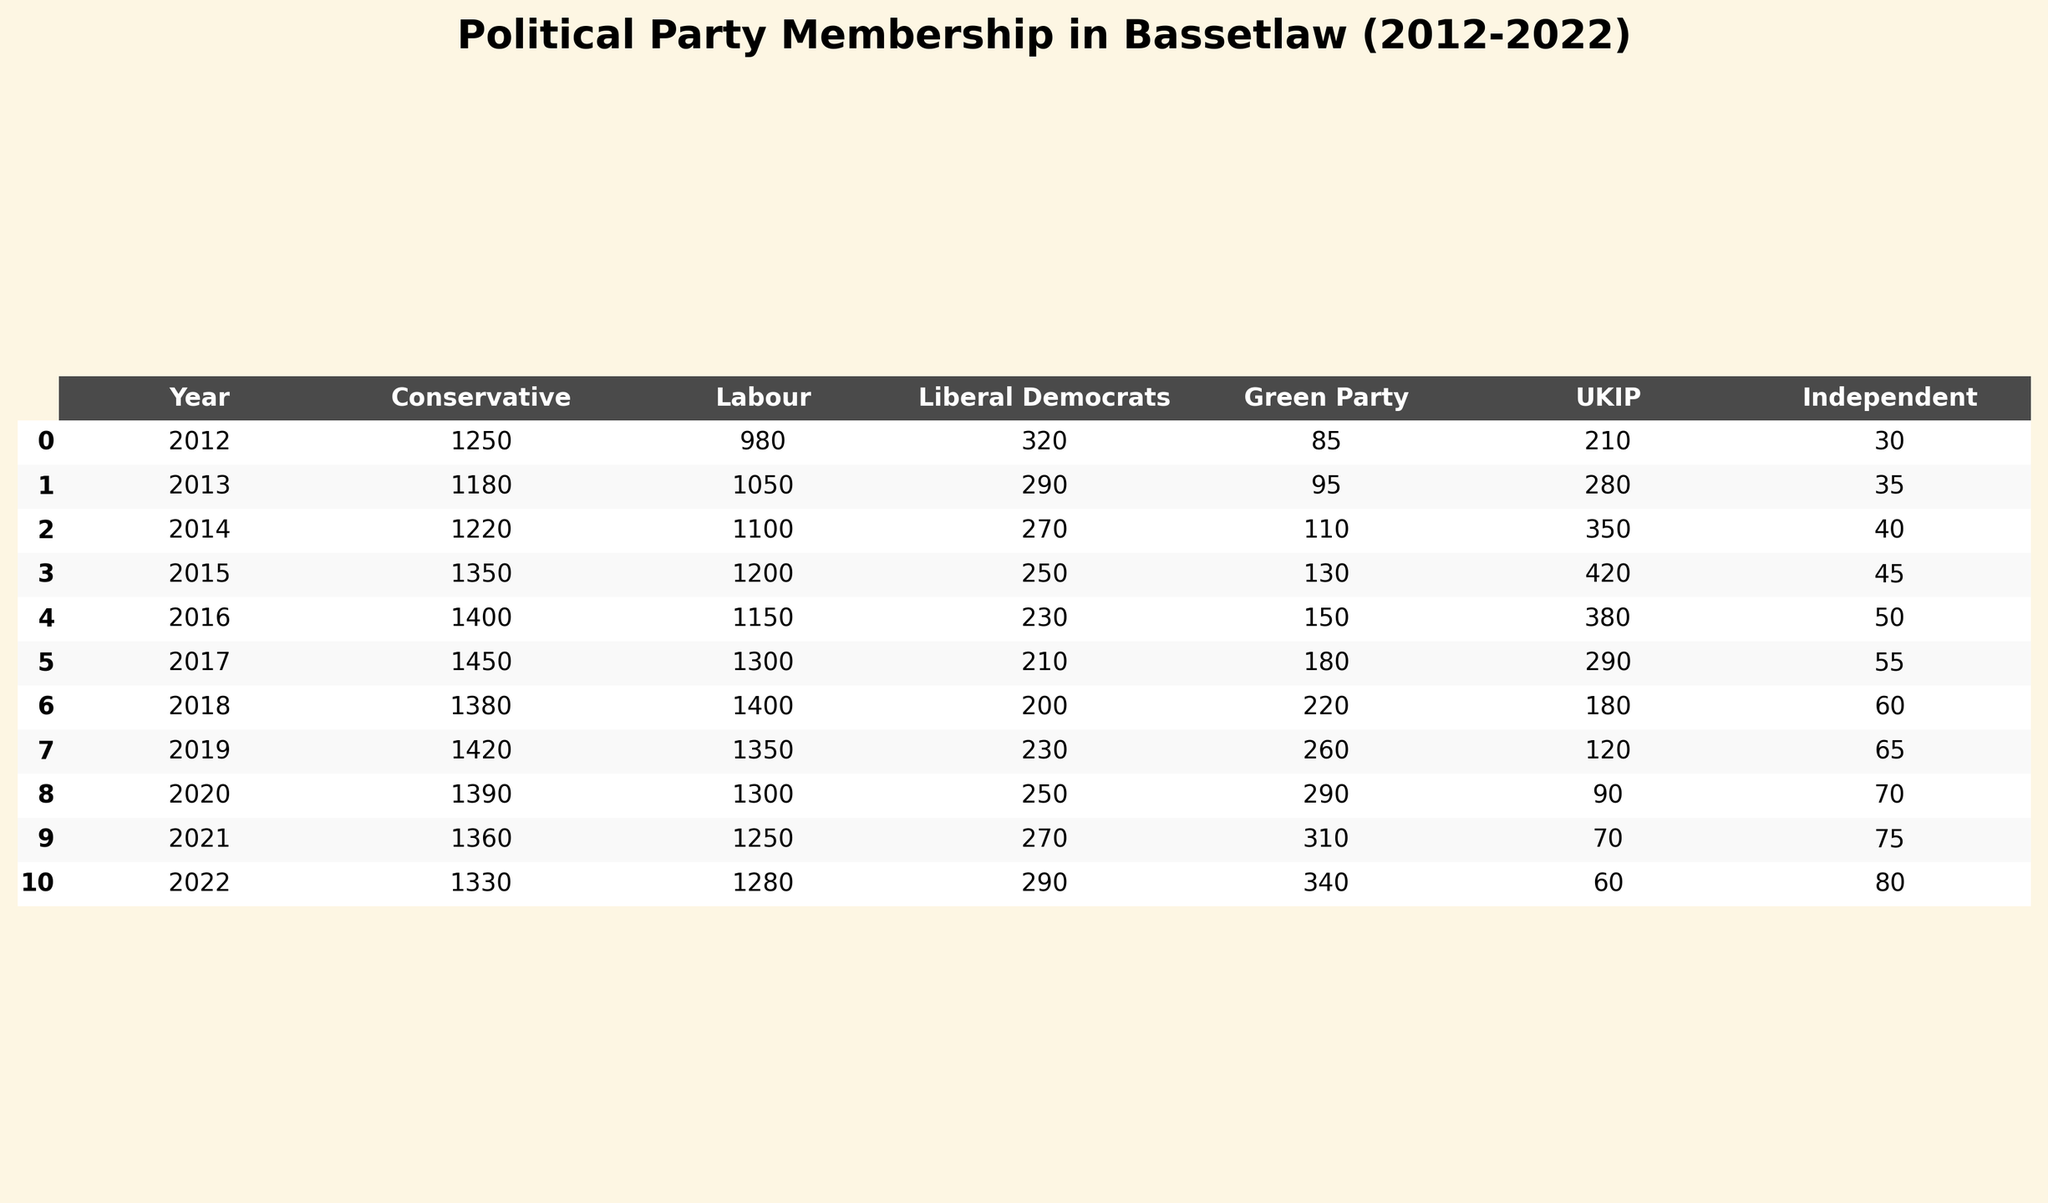What was the membership number of the Labour Party in 2020? In 2020, the Labour Party membership number is listed directly in the table under the 'Labour' column for the year '2020', which shows a value of 1300.
Answer: 1300 What is the total membership for all political parties in Bassetlaw in 2015? To calculate the total for 2015, I sum the values from all parties: 1350 (Conservative) + 1200 (Labour) + 250 (Liberal Democrats) + 130 (Green Party) + 420 (UKIP) + 45 (Independent) = 3375.
Answer: 3375 Did the Conservative Party membership ever drop below 1200 in the decade? By reviewing the values in the Conservative column across all years, I find that the lowest membership number is 1180 in 2013 which is indeed below 1200.
Answer: Yes In which year did the Liberal Democrats have their highest membership? The Liberal Democrats column shows the highest value in 2012 with 320 members. I find that after that year, the values are lower in subsequent years up to 2022.
Answer: 2012 What was the change in membership of the Green Party from 2012 to 2022? For 2012, the Green Party's membership was 85, and in 2022 it was 340. The change can be calculated as 340 - 85 = 255, indicating an increase.
Answer: 255 What is the average membership number for the UKIP across the decade? To find the average, I first sum the UKIP membership figures from each year: 210 + 280 + 350 + 420 + 380 + 290 + 180 + 120 + 90 + 70 + 60 = 2430. There are 11 data points (years), so the average is 2430 / 11 = 221.82, which is approximately 222.
Answer: 222 Which party had the least number of members in 2014? Looking at the table for 2014, I compare all party membership values: Conservative 1220, Labour 1100, Liberal Democrats 270, Green Party 110, UKIP 350, Independent 40. The least is 40 for Independents.
Answer: Independent How many years did the Labour Party's membership exceed 1300? By checking the Labour column in the table, I see the values are: 980, 1050, 1100, 1200, 1150, 1300, 1400, 1350, 1300, 1250, 1280. The only years over 1300 are 2018 and 2019, making it 2 years.
Answer: 2 What was the largest difference in membership numbers between the Conservative Party and Labour Party in this decade? I find the largest Conservative number is 1450 in 2017 and the lowest Labour number is 980 in 2012. The difference then is calculated as 1450 - 980 = 470. No other years show a greater difference.
Answer: 470 What trend can be observed in the membership of the Independent Party over the decade? By analyzing the Independent values (30, 35, 40, 45, 50, 55, 60, 65, 70, 75, 80), it's clear they are consistently increasing year on year.
Answer: Consistent increase 